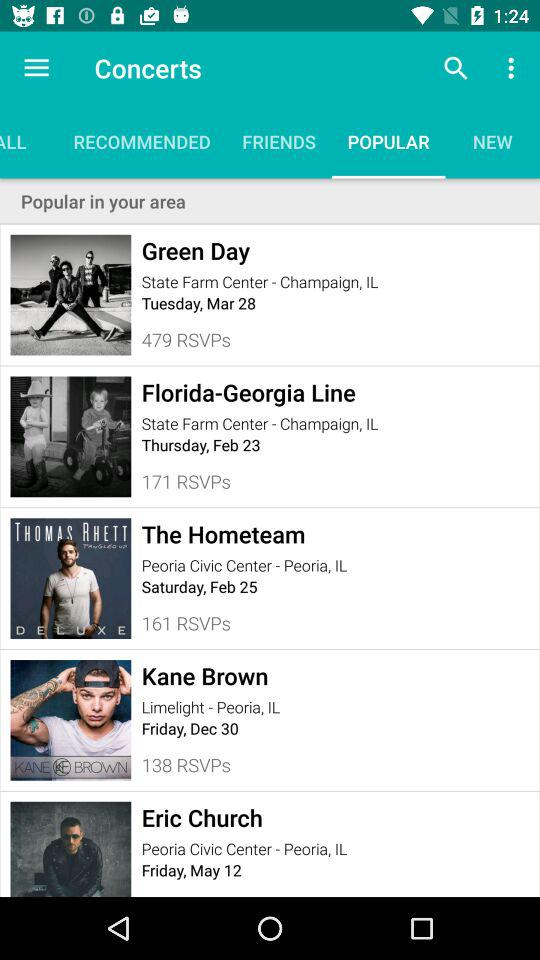Which tab is selected? The selected tab is "POPULAR". 